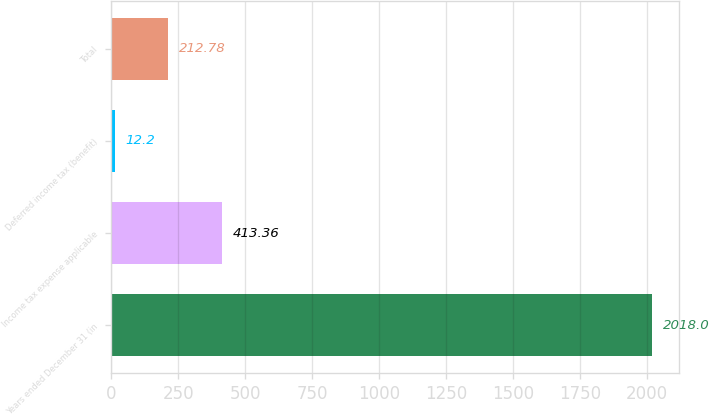Convert chart to OTSL. <chart><loc_0><loc_0><loc_500><loc_500><bar_chart><fcel>Years ended December 31 (in<fcel>Income tax expense applicable<fcel>Deferred income tax (benefit)<fcel>Total<nl><fcel>2018<fcel>413.36<fcel>12.2<fcel>212.78<nl></chart> 